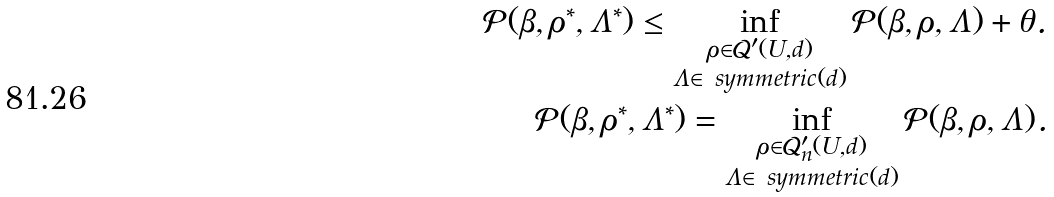Convert formula to latex. <formula><loc_0><loc_0><loc_500><loc_500>\mathcal { P } ( \beta , \rho ^ { * } , \Lambda ^ { * } ) \leq \inf _ { \substack { \rho \in \mathcal { Q } ^ { \prime } ( U , d ) \\ \Lambda \in \ s y m m e t r i c ( d ) } } \mathcal { P } ( \beta , \rho , \Lambda ) + \theta . \\ \mathcal { P } ( \beta , \rho ^ { * } , \Lambda ^ { * } ) = \inf _ { \substack { \rho \in \mathcal { Q } ^ { \prime } _ { n } ( U , d ) \\ \Lambda \in \ s y m m e t r i c ( d ) } } \mathcal { P } ( \beta , \rho , \Lambda ) .</formula> 